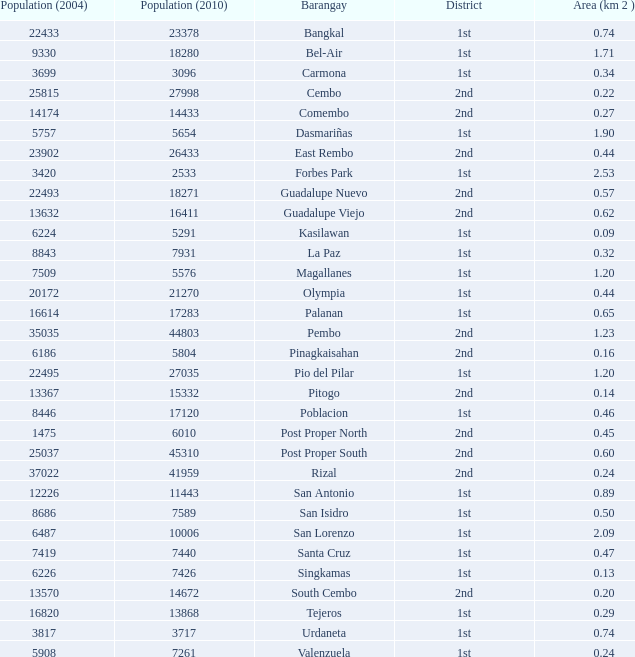What is the area where barangay is guadalupe viejo? 0.62. 